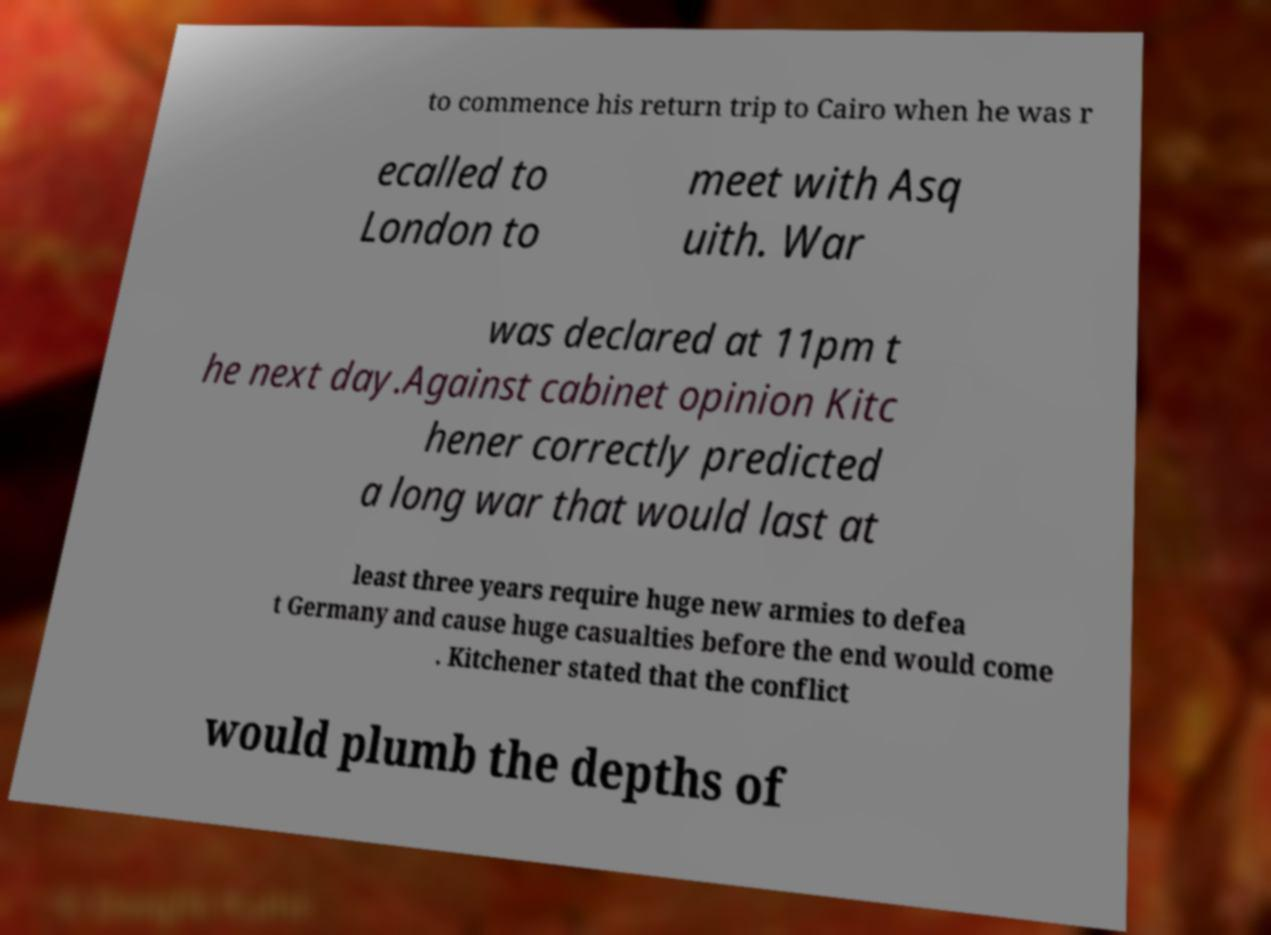I need the written content from this picture converted into text. Can you do that? to commence his return trip to Cairo when he was r ecalled to London to meet with Asq uith. War was declared at 11pm t he next day.Against cabinet opinion Kitc hener correctly predicted a long war that would last at least three years require huge new armies to defea t Germany and cause huge casualties before the end would come . Kitchener stated that the conflict would plumb the depths of 